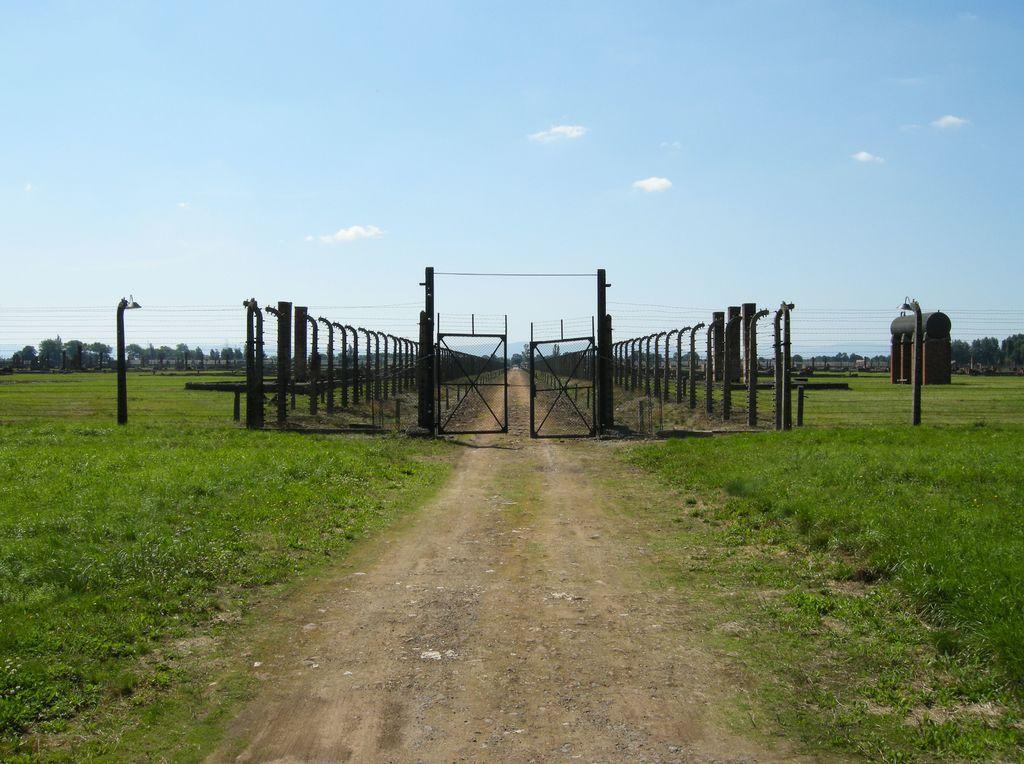Please provide a concise description of this image. In this image I can see few poles, wires, gate, trees and brown and black color object. I can see the green color grass. The sky is in white and blue color. 